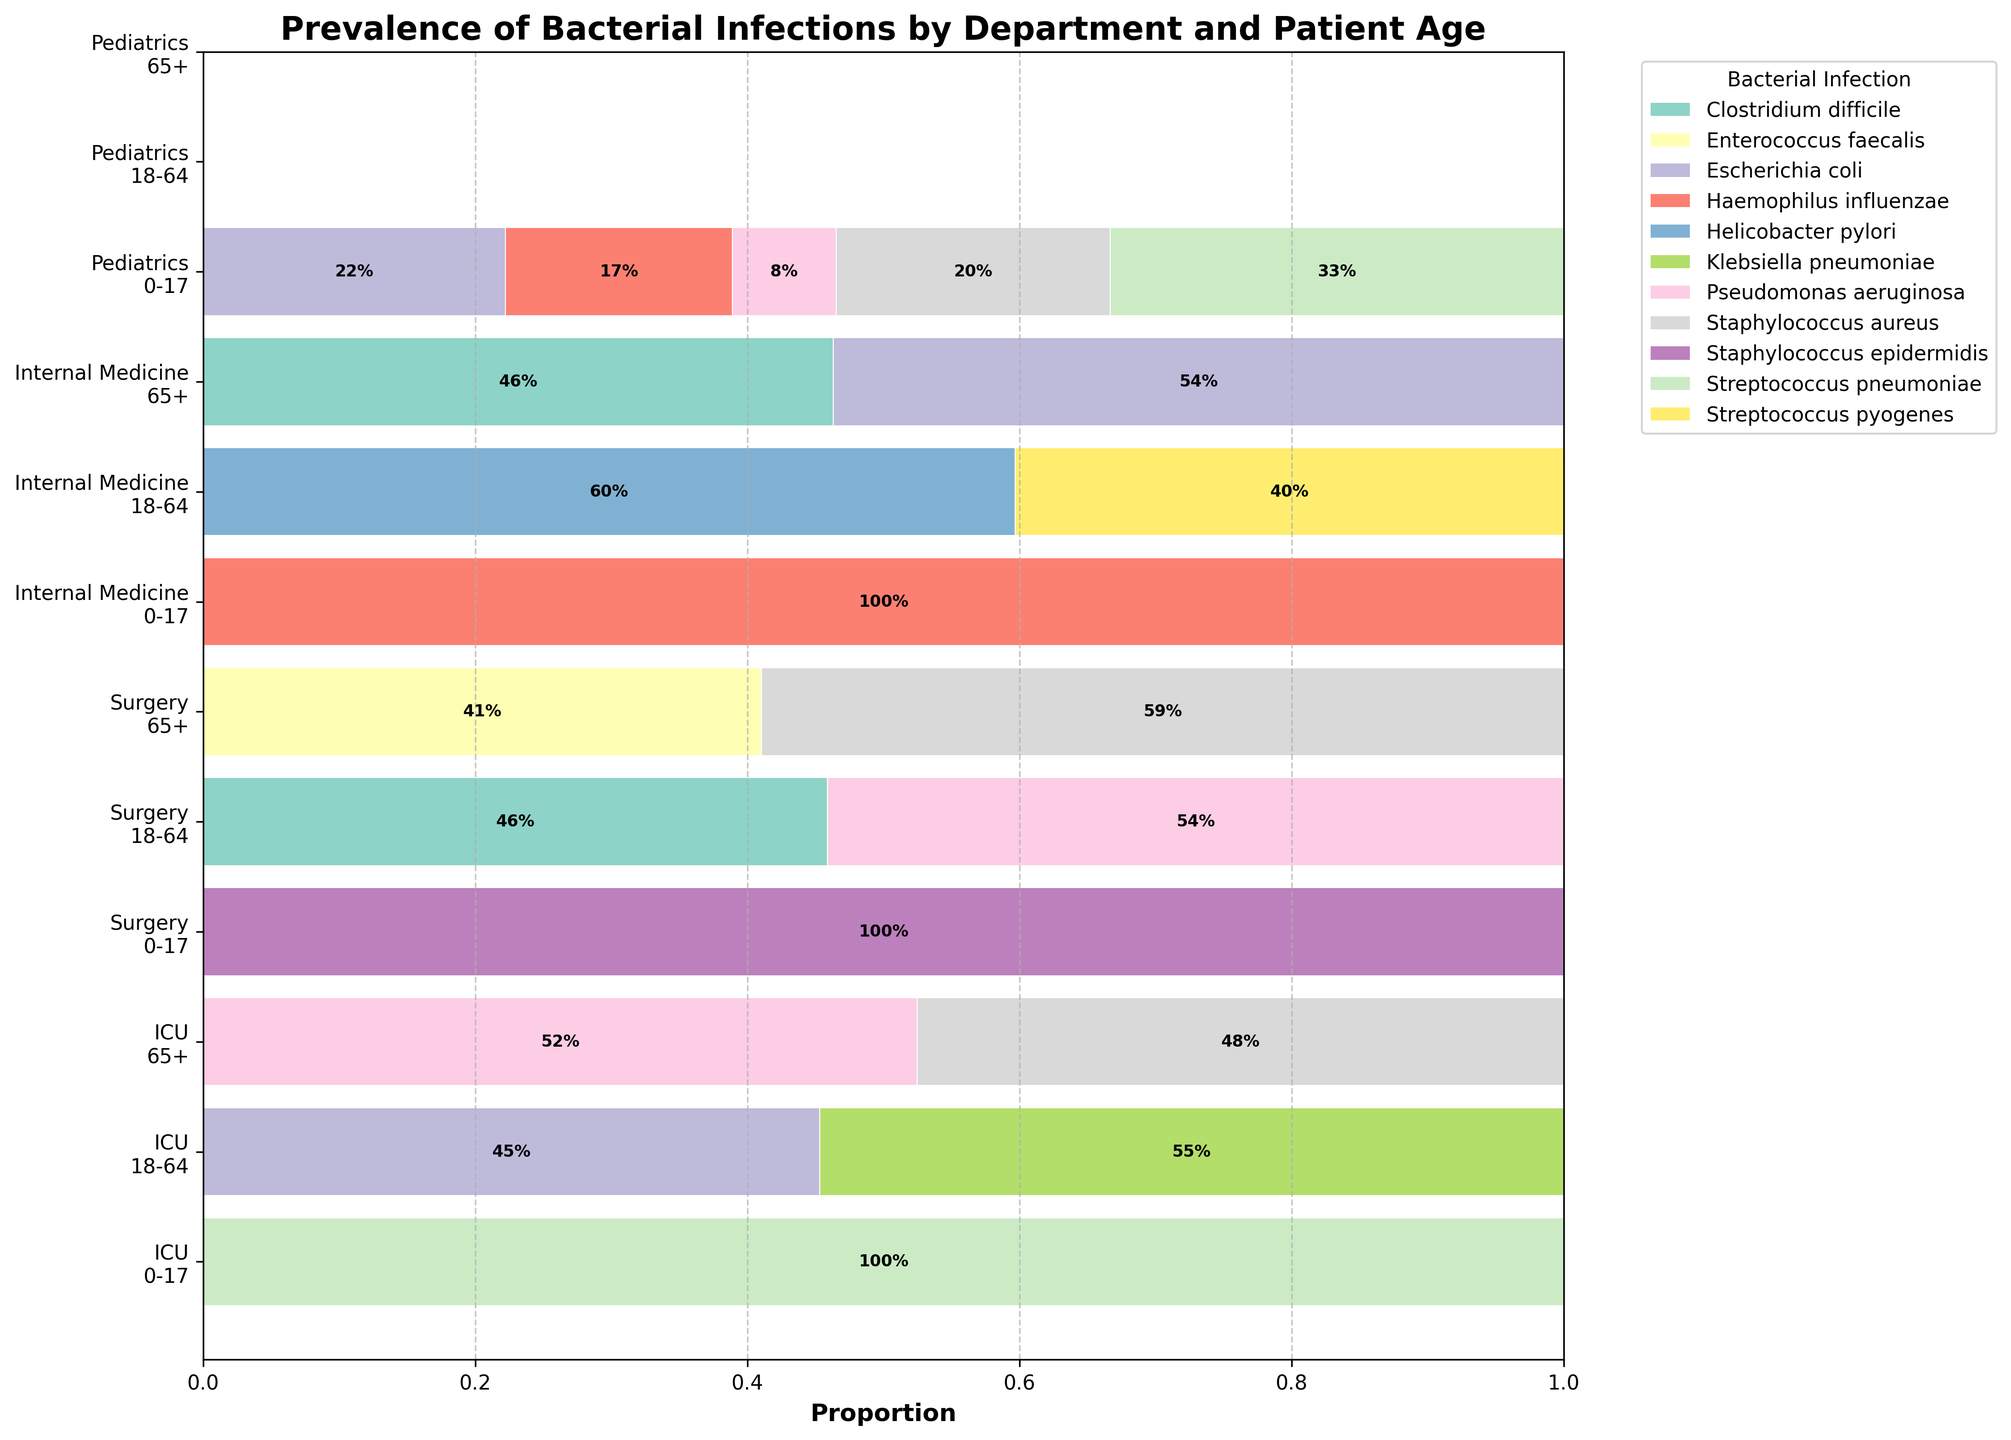What is the title of the plot? The title of the plot is written at the top of the figure in larger and bolder text. It serves to introduce the viewer to the main subject of the plot.
Answer: Prevalence of Bacterial Infections by Department and Patient Age Which department has the highest proportion of 'Staphylococcus aureus' infections in the 65+ age group? To determine this, look at the horizontal bars corresponding to the '65+' age group across different departments. Locate the segment labeled 'Staphylococcus aureus' and compare their sizes.
Answer: Surgery What is the total number of different bacterial infections represented in the plot? Count the distinct colors or labels corresponding to different bacterial infections in the legend. Each color/label represents a different bacterial infection.
Answer: Nine Comparing 'ICU' and 'Surgery' departments, which one has a higher proportion of 'Pseudomonas aeruginosa' infections in the 18-64 age group? Identify the 'ICU' and 'Surgery' sections for the '18-64' age group and locate the segments for 'Pseudomonas aeruginosa'. Compare their sizes.
Answer: ICU What is the proportion of 'Escherichia coli' infections in the 'Internal Medicine' department for the 65+ age group? Look at the 'Internal Medicine' section for the '65+' age group and find the segment for 'Escherichia coli'. The proportion is marked within the bar segment.
Answer: 0.26 (26%) Which bacterial infection is most prevalent in Pediatrics for patients aged 0-17? Within the 'Pediatrics' section for the '0-17' age group, identify the largest segment, as this indicates the most prevalent bacterial infection.
Answer: Streptococcus pneumoniae Does 'Streptococcus pyogenes' appear in any other department besides 'Internal Medicine'? If so, specify the age group and department. Examine all segments for each department and locate any instances of 'Streptococcus pyogenes' other than 'Internal Medicine'.
Answer: No, it only appears in Internal Medicine How does the proportion of 'Haemophilus influenzae' infections in Pediatrics (0-17) compare to that in Internal Medicine (0-17)? Look at the 'Pediatrics' and 'Internal Medicine' sections for the '0-17' age group, and compare the segments for 'Haemophilus influenzae'.
Answer: Pediatrics has a higher proportion Which department has the most evenly distributed bacterial infections for the 18-64 age group? Compare the sections for the '18-64' age group across different departments. The one with segments of relatively equal sizes represents the most evenly distributed infections.
Answer: Internal Medicine 